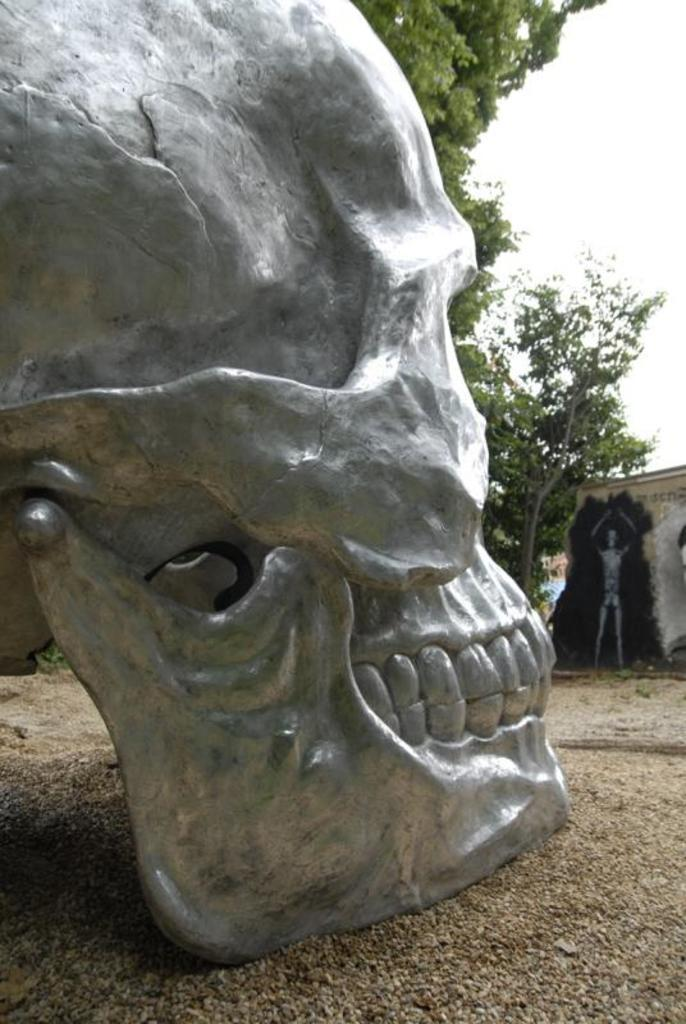What is the main subject of the image? The main subject of the image is a skull statue. Where is the skull statue located? The skull statue is on the land. What can be seen in the background of the image? There are trees behind the skull statue in the image. What type of sheet is covering the skull statue in the image? There is no sheet covering the skull statue in the image; it is visible and not obscured. 